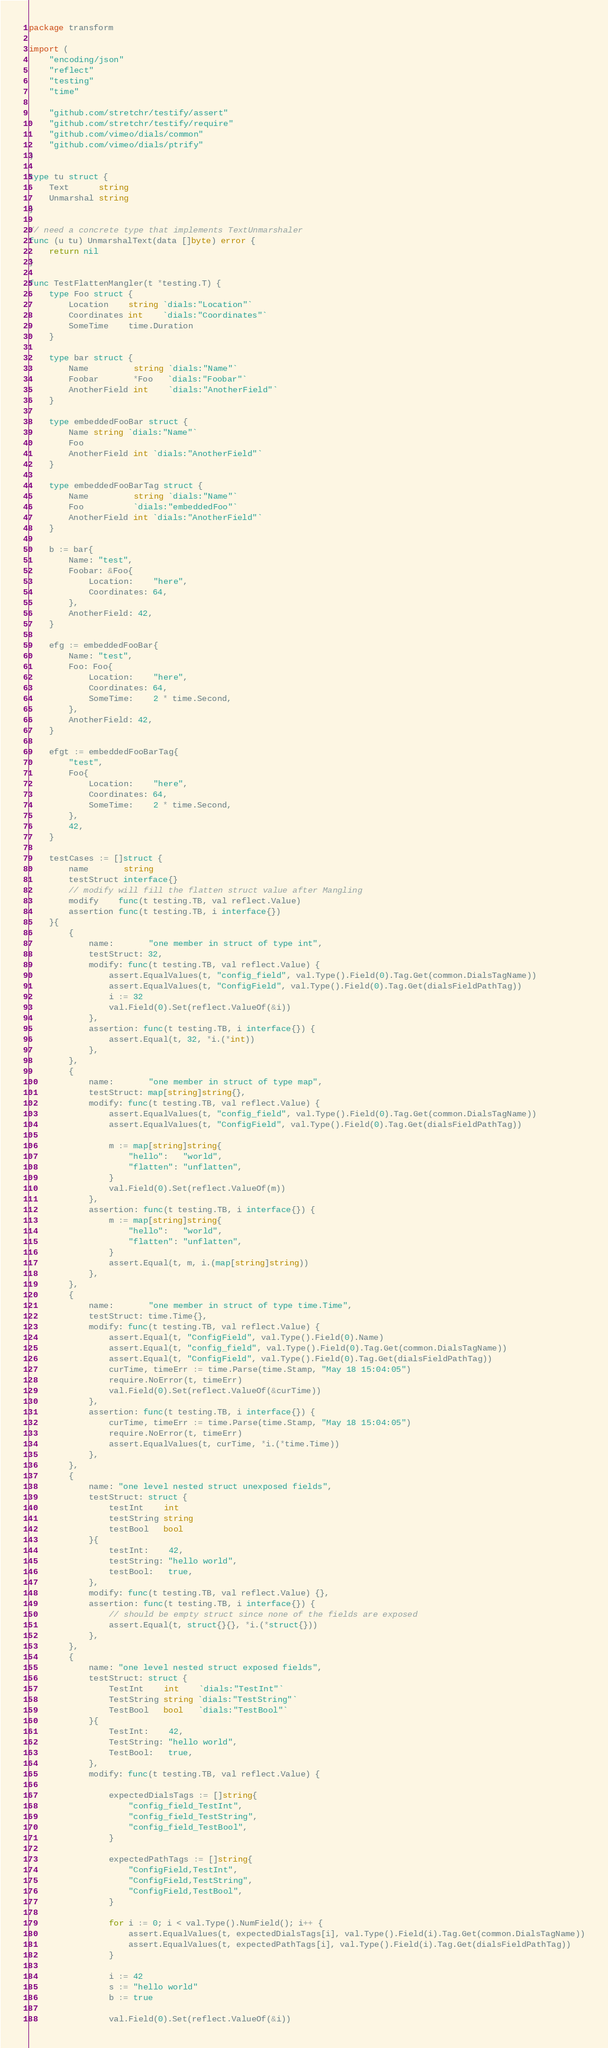<code> <loc_0><loc_0><loc_500><loc_500><_Go_>package transform

import (
	"encoding/json"
	"reflect"
	"testing"
	"time"

	"github.com/stretchr/testify/assert"
	"github.com/stretchr/testify/require"
	"github.com/vimeo/dials/common"
	"github.com/vimeo/dials/ptrify"
)

type tu struct {
	Text      string
	Unmarshal string
}

// need a concrete type that implements TextUnmarshaler
func (u tu) UnmarshalText(data []byte) error {
	return nil
}

func TestFlattenMangler(t *testing.T) {
	type Foo struct {
		Location    string `dials:"Location"`
		Coordinates int    `dials:"Coordinates"`
		SomeTime    time.Duration
	}

	type bar struct {
		Name         string `dials:"Name"`
		Foobar       *Foo   `dials:"Foobar"`
		AnotherField int    `dials:"AnotherField"`
	}

	type embeddedFooBar struct {
		Name string `dials:"Name"`
		Foo
		AnotherField int `dials:"AnotherField"`
	}

	type embeddedFooBarTag struct {
		Name         string `dials:"Name"`
		Foo          `dials:"embeddedFoo"`
		AnotherField int `dials:"AnotherField"`
	}

	b := bar{
		Name: "test",
		Foobar: &Foo{
			Location:    "here",
			Coordinates: 64,
		},
		AnotherField: 42,
	}

	efg := embeddedFooBar{
		Name: "test",
		Foo: Foo{
			Location:    "here",
			Coordinates: 64,
			SomeTime:    2 * time.Second,
		},
		AnotherField: 42,
	}

	efgt := embeddedFooBarTag{
		"test",
		Foo{
			Location:    "here",
			Coordinates: 64,
			SomeTime:    2 * time.Second,
		},
		42,
	}

	testCases := []struct {
		name       string
		testStruct interface{}
		// modify will fill the flatten struct value after Mangling
		modify    func(t testing.TB, val reflect.Value)
		assertion func(t testing.TB, i interface{})
	}{
		{
			name:       "one member in struct of type int",
			testStruct: 32,
			modify: func(t testing.TB, val reflect.Value) {
				assert.EqualValues(t, "config_field", val.Type().Field(0).Tag.Get(common.DialsTagName))
				assert.EqualValues(t, "ConfigField", val.Type().Field(0).Tag.Get(dialsFieldPathTag))
				i := 32
				val.Field(0).Set(reflect.ValueOf(&i))
			},
			assertion: func(t testing.TB, i interface{}) {
				assert.Equal(t, 32, *i.(*int))
			},
		},
		{
			name:       "one member in struct of type map",
			testStruct: map[string]string{},
			modify: func(t testing.TB, val reflect.Value) {
				assert.EqualValues(t, "config_field", val.Type().Field(0).Tag.Get(common.DialsTagName))
				assert.EqualValues(t, "ConfigField", val.Type().Field(0).Tag.Get(dialsFieldPathTag))

				m := map[string]string{
					"hello":   "world",
					"flatten": "unflatten",
				}
				val.Field(0).Set(reflect.ValueOf(m))
			},
			assertion: func(t testing.TB, i interface{}) {
				m := map[string]string{
					"hello":   "world",
					"flatten": "unflatten",
				}
				assert.Equal(t, m, i.(map[string]string))
			},
		},
		{
			name:       "one member in struct of type time.Time",
			testStruct: time.Time{},
			modify: func(t testing.TB, val reflect.Value) {
				assert.Equal(t, "ConfigField", val.Type().Field(0).Name)
				assert.Equal(t, "config_field", val.Type().Field(0).Tag.Get(common.DialsTagName))
				assert.Equal(t, "ConfigField", val.Type().Field(0).Tag.Get(dialsFieldPathTag))
				curTime, timeErr := time.Parse(time.Stamp, "May 18 15:04:05")
				require.NoError(t, timeErr)
				val.Field(0).Set(reflect.ValueOf(&curTime))
			},
			assertion: func(t testing.TB, i interface{}) {
				curTime, timeErr := time.Parse(time.Stamp, "May 18 15:04:05")
				require.NoError(t, timeErr)
				assert.EqualValues(t, curTime, *i.(*time.Time))
			},
		},
		{
			name: "one level nested struct unexposed fields",
			testStruct: struct {
				testInt    int
				testString string
				testBool   bool
			}{
				testInt:    42,
				testString: "hello world",
				testBool:   true,
			},
			modify: func(t testing.TB, val reflect.Value) {},
			assertion: func(t testing.TB, i interface{}) {
				// should be empty struct since none of the fields are exposed
				assert.Equal(t, struct{}{}, *i.(*struct{}))
			},
		},
		{
			name: "one level nested struct exposed fields",
			testStruct: struct {
				TestInt    int    `dials:"TestInt"`
				TestString string `dials:"TestString"`
				TestBool   bool   `dials:"TestBool"`
			}{
				TestInt:    42,
				TestString: "hello world",
				TestBool:   true,
			},
			modify: func(t testing.TB, val reflect.Value) {

				expectedDialsTags := []string{
					"config_field_TestInt",
					"config_field_TestString",
					"config_field_TestBool",
				}

				expectedPathTags := []string{
					"ConfigField,TestInt",
					"ConfigField,TestString",
					"ConfigField,TestBool",
				}

				for i := 0; i < val.Type().NumField(); i++ {
					assert.EqualValues(t, expectedDialsTags[i], val.Type().Field(i).Tag.Get(common.DialsTagName))
					assert.EqualValues(t, expectedPathTags[i], val.Type().Field(i).Tag.Get(dialsFieldPathTag))
				}

				i := 42
				s := "hello world"
				b := true

				val.Field(0).Set(reflect.ValueOf(&i))</code> 